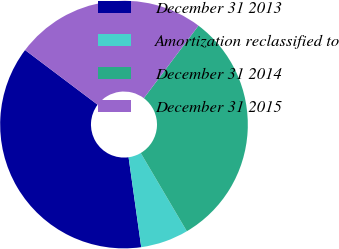Convert chart. <chart><loc_0><loc_0><loc_500><loc_500><pie_chart><fcel>December 31 2013<fcel>Amortization reclassified to<fcel>December 31 2014<fcel>December 31 2015<nl><fcel>37.5%<fcel>6.25%<fcel>31.25%<fcel>25.0%<nl></chart> 